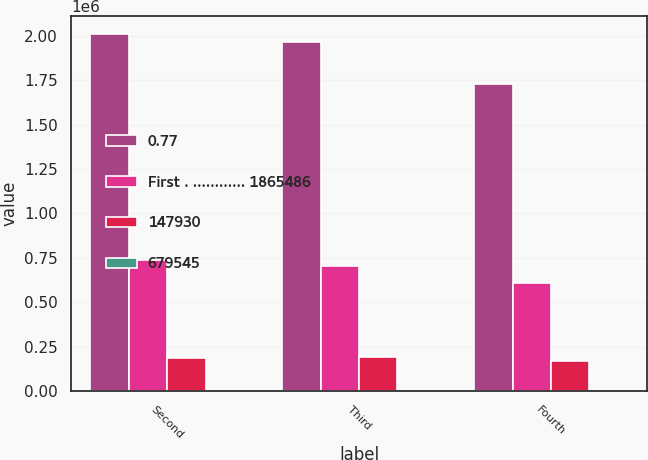Convert chart to OTSL. <chart><loc_0><loc_0><loc_500><loc_500><stacked_bar_chart><ecel><fcel>Second<fcel>Third<fcel>Fourth<nl><fcel>0.77<fcel>2.01098e+06<fcel>1.96578e+06<fcel>1.72665e+06<nl><fcel>First . ............ 1865486<fcel>739620<fcel>704343<fcel>606499<nl><fcel>147930<fcel>186911<fcel>190335<fcel>169582<nl><fcel>679545<fcel>0.99<fcel>1.02<fcel>0.91<nl></chart> 